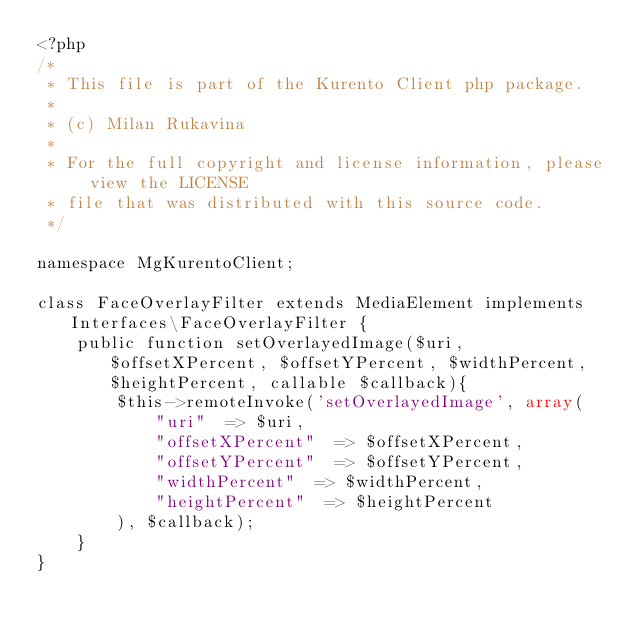Convert code to text. <code><loc_0><loc_0><loc_500><loc_500><_PHP_><?php
/*
 * This file is part of the Kurento Client php package.
 *
 * (c) Milan Rukavina
 *
 * For the full copyright and license information, please view the LICENSE
 * file that was distributed with this source code.
 */

namespace MgKurentoClient;

class FaceOverlayFilter extends MediaElement implements Interfaces\FaceOverlayFilter {
    public function setOverlayedImage($uri, $offsetXPercent, $offsetYPercent, $widthPercent, $heightPercent, callable $callback){
        $this->remoteInvoke('setOverlayedImage', array(
            "uri"  => $uri,
            "offsetXPercent"  => $offsetXPercent,
            "offsetYPercent"  => $offsetYPercent,
            "widthPercent"  => $widthPercent,
            "heightPercent"  => $heightPercent
        ), $callback);
    }    
}
</code> 